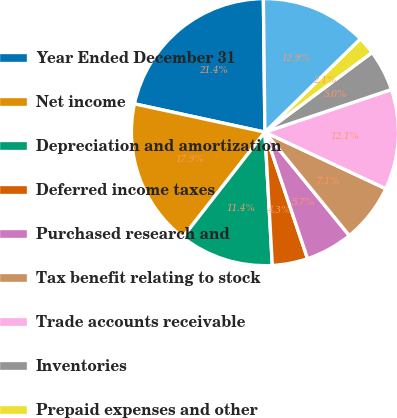Convert chart to OTSL. <chart><loc_0><loc_0><loc_500><loc_500><pie_chart><fcel>Year Ended December 31<fcel>Net income<fcel>Depreciation and amortization<fcel>Deferred income taxes<fcel>Purchased research and<fcel>Tax benefit relating to stock<fcel>Trade accounts receivable<fcel>Inventories<fcel>Prepaid expenses and other<fcel>Accounts payable and accrued<nl><fcel>21.42%<fcel>17.85%<fcel>11.43%<fcel>4.29%<fcel>5.72%<fcel>7.14%<fcel>12.14%<fcel>5.0%<fcel>2.15%<fcel>12.86%<nl></chart> 